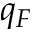Convert formula to latex. <formula><loc_0><loc_0><loc_500><loc_500>q _ { F }</formula> 